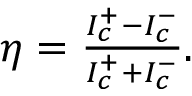<formula> <loc_0><loc_0><loc_500><loc_500>\begin{array} { r } { \eta = \frac { I _ { c } ^ { + } - I _ { c } ^ { - } } { I _ { c } ^ { + } + I _ { c } ^ { - } } . } \end{array}</formula> 